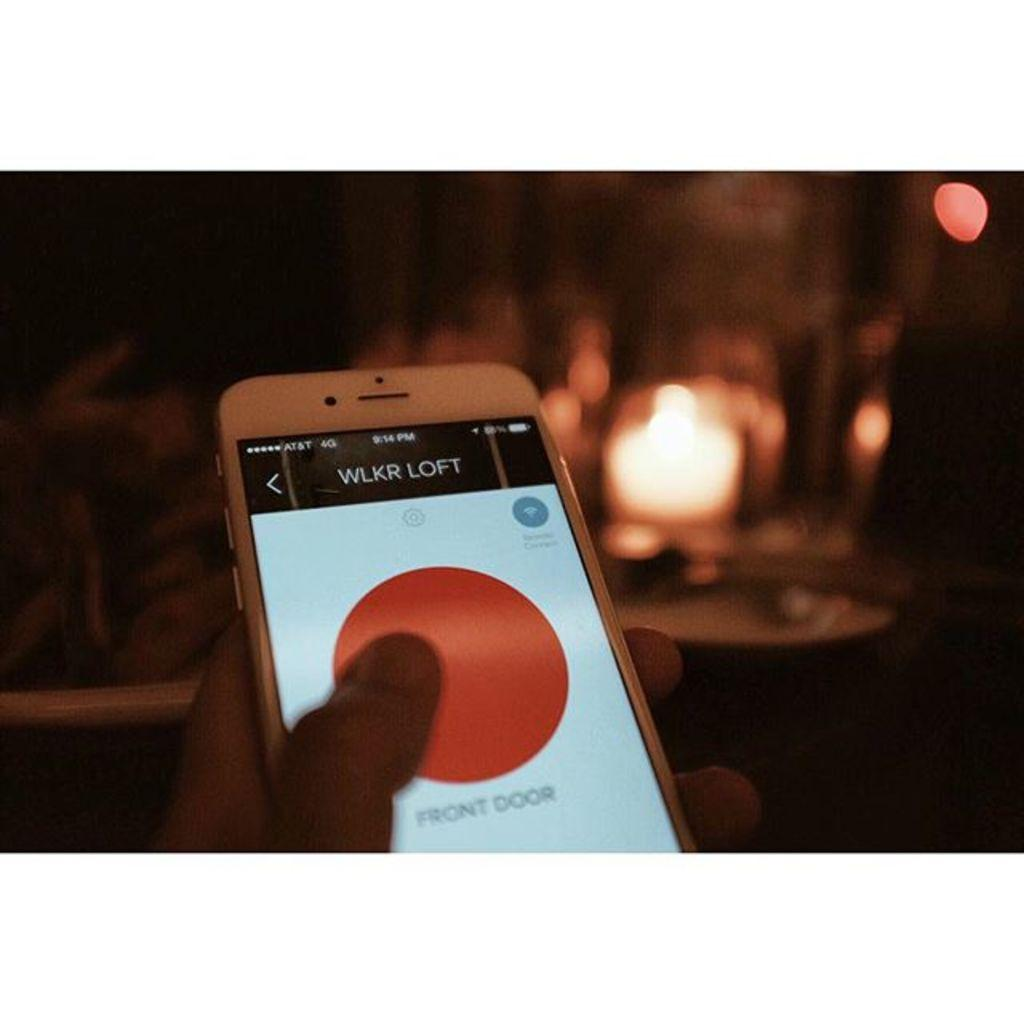<image>
Present a compact description of the photo's key features. a white front faced iphone turned on to a screen that says 'wlkr loft' 